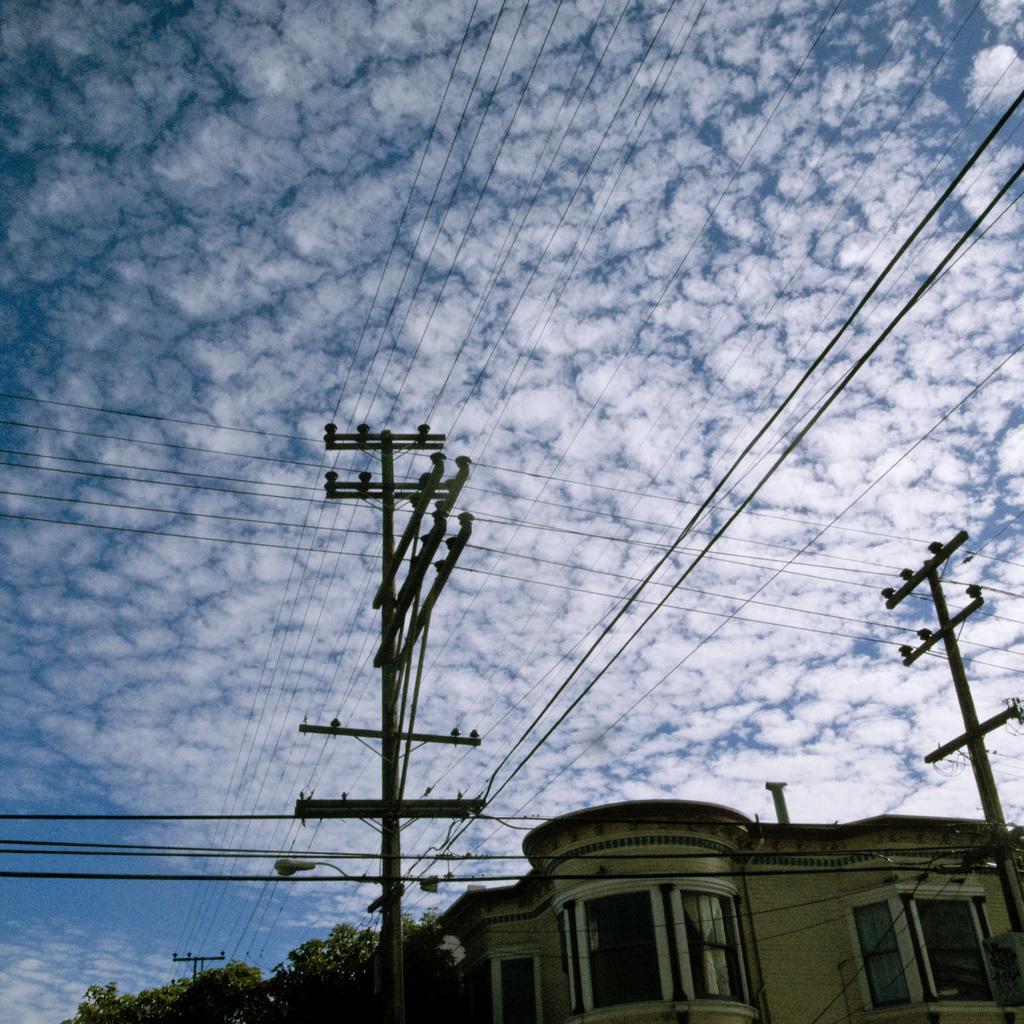How would you summarize this image in a sentence or two? In the image we can see a building and the windows of the building. There are electric poles and electric wires, we can see even trees and cloudy sky. 